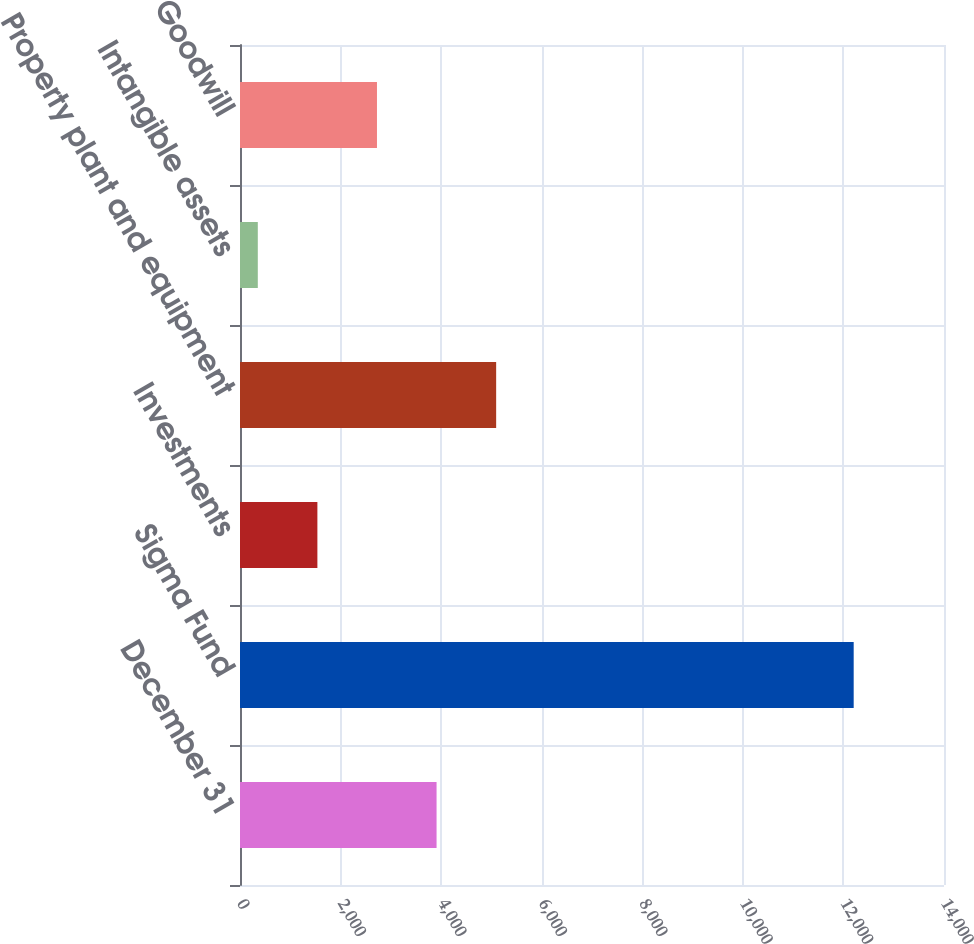Convert chart. <chart><loc_0><loc_0><loc_500><loc_500><bar_chart><fcel>December 31<fcel>Sigma Fund<fcel>Investments<fcel>Property plant and equipment<fcel>Intangible assets<fcel>Goodwill<nl><fcel>3909<fcel>12204<fcel>1539<fcel>5094<fcel>354<fcel>2724<nl></chart> 